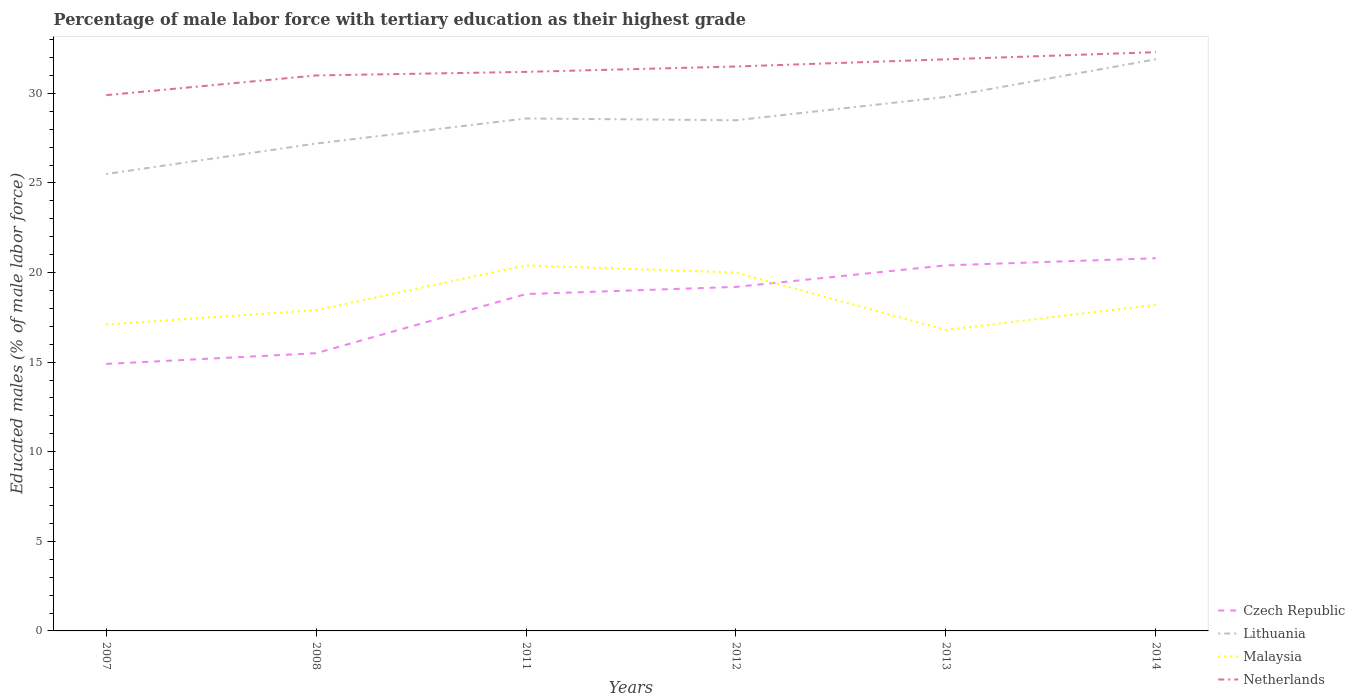How many different coloured lines are there?
Your answer should be very brief. 4. Does the line corresponding to Malaysia intersect with the line corresponding to Lithuania?
Offer a very short reply. No. Across all years, what is the maximum percentage of male labor force with tertiary education in Czech Republic?
Keep it short and to the point. 14.9. What is the total percentage of male labor force with tertiary education in Czech Republic in the graph?
Your answer should be very brief. -0.4. What is the difference between the highest and the second highest percentage of male labor force with tertiary education in Czech Republic?
Give a very brief answer. 5.9. What is the difference between the highest and the lowest percentage of male labor force with tertiary education in Czech Republic?
Keep it short and to the point. 4. Does the graph contain any zero values?
Provide a short and direct response. No. Does the graph contain grids?
Ensure brevity in your answer.  No. How many legend labels are there?
Your answer should be compact. 4. What is the title of the graph?
Provide a short and direct response. Percentage of male labor force with tertiary education as their highest grade. Does "Qatar" appear as one of the legend labels in the graph?
Offer a terse response. No. What is the label or title of the Y-axis?
Offer a very short reply. Educated males (% of male labor force). What is the Educated males (% of male labor force) in Czech Republic in 2007?
Your response must be concise. 14.9. What is the Educated males (% of male labor force) of Malaysia in 2007?
Your answer should be very brief. 17.1. What is the Educated males (% of male labor force) in Netherlands in 2007?
Give a very brief answer. 29.9. What is the Educated males (% of male labor force) of Czech Republic in 2008?
Ensure brevity in your answer.  15.5. What is the Educated males (% of male labor force) of Lithuania in 2008?
Ensure brevity in your answer.  27.2. What is the Educated males (% of male labor force) in Malaysia in 2008?
Ensure brevity in your answer.  17.9. What is the Educated males (% of male labor force) in Netherlands in 2008?
Ensure brevity in your answer.  31. What is the Educated males (% of male labor force) in Czech Republic in 2011?
Ensure brevity in your answer.  18.8. What is the Educated males (% of male labor force) of Lithuania in 2011?
Your response must be concise. 28.6. What is the Educated males (% of male labor force) in Malaysia in 2011?
Keep it short and to the point. 20.4. What is the Educated males (% of male labor force) in Netherlands in 2011?
Offer a terse response. 31.2. What is the Educated males (% of male labor force) of Czech Republic in 2012?
Keep it short and to the point. 19.2. What is the Educated males (% of male labor force) of Lithuania in 2012?
Offer a very short reply. 28.5. What is the Educated males (% of male labor force) of Netherlands in 2012?
Your answer should be compact. 31.5. What is the Educated males (% of male labor force) in Czech Republic in 2013?
Provide a succinct answer. 20.4. What is the Educated males (% of male labor force) in Lithuania in 2013?
Give a very brief answer. 29.8. What is the Educated males (% of male labor force) of Malaysia in 2013?
Your answer should be very brief. 16.8. What is the Educated males (% of male labor force) in Netherlands in 2013?
Keep it short and to the point. 31.9. What is the Educated males (% of male labor force) in Czech Republic in 2014?
Provide a short and direct response. 20.8. What is the Educated males (% of male labor force) of Lithuania in 2014?
Give a very brief answer. 31.9. What is the Educated males (% of male labor force) in Malaysia in 2014?
Provide a succinct answer. 18.2. What is the Educated males (% of male labor force) of Netherlands in 2014?
Your response must be concise. 32.3. Across all years, what is the maximum Educated males (% of male labor force) of Czech Republic?
Your response must be concise. 20.8. Across all years, what is the maximum Educated males (% of male labor force) in Lithuania?
Make the answer very short. 31.9. Across all years, what is the maximum Educated males (% of male labor force) of Malaysia?
Offer a terse response. 20.4. Across all years, what is the maximum Educated males (% of male labor force) of Netherlands?
Give a very brief answer. 32.3. Across all years, what is the minimum Educated males (% of male labor force) in Czech Republic?
Offer a terse response. 14.9. Across all years, what is the minimum Educated males (% of male labor force) of Lithuania?
Ensure brevity in your answer.  25.5. Across all years, what is the minimum Educated males (% of male labor force) in Malaysia?
Offer a very short reply. 16.8. Across all years, what is the minimum Educated males (% of male labor force) of Netherlands?
Make the answer very short. 29.9. What is the total Educated males (% of male labor force) in Czech Republic in the graph?
Offer a very short reply. 109.6. What is the total Educated males (% of male labor force) of Lithuania in the graph?
Your response must be concise. 171.5. What is the total Educated males (% of male labor force) of Malaysia in the graph?
Provide a short and direct response. 110.4. What is the total Educated males (% of male labor force) in Netherlands in the graph?
Provide a short and direct response. 187.8. What is the difference between the Educated males (% of male labor force) of Czech Republic in 2007 and that in 2008?
Offer a very short reply. -0.6. What is the difference between the Educated males (% of male labor force) of Lithuania in 2007 and that in 2008?
Your answer should be compact. -1.7. What is the difference between the Educated males (% of male labor force) of Malaysia in 2007 and that in 2008?
Provide a short and direct response. -0.8. What is the difference between the Educated males (% of male labor force) in Czech Republic in 2007 and that in 2011?
Make the answer very short. -3.9. What is the difference between the Educated males (% of male labor force) in Malaysia in 2007 and that in 2011?
Give a very brief answer. -3.3. What is the difference between the Educated males (% of male labor force) of Lithuania in 2007 and that in 2012?
Keep it short and to the point. -3. What is the difference between the Educated males (% of male labor force) of Lithuania in 2007 and that in 2013?
Offer a very short reply. -4.3. What is the difference between the Educated males (% of male labor force) of Malaysia in 2007 and that in 2013?
Provide a succinct answer. 0.3. What is the difference between the Educated males (% of male labor force) in Netherlands in 2007 and that in 2013?
Give a very brief answer. -2. What is the difference between the Educated males (% of male labor force) of Netherlands in 2007 and that in 2014?
Give a very brief answer. -2.4. What is the difference between the Educated males (% of male labor force) of Czech Republic in 2008 and that in 2011?
Your answer should be compact. -3.3. What is the difference between the Educated males (% of male labor force) in Netherlands in 2008 and that in 2011?
Offer a terse response. -0.2. What is the difference between the Educated males (% of male labor force) in Czech Republic in 2008 and that in 2012?
Offer a very short reply. -3.7. What is the difference between the Educated males (% of male labor force) of Malaysia in 2008 and that in 2012?
Offer a terse response. -2.1. What is the difference between the Educated males (% of male labor force) of Malaysia in 2008 and that in 2013?
Offer a very short reply. 1.1. What is the difference between the Educated males (% of male labor force) of Netherlands in 2008 and that in 2013?
Offer a terse response. -0.9. What is the difference between the Educated males (% of male labor force) in Czech Republic in 2008 and that in 2014?
Offer a very short reply. -5.3. What is the difference between the Educated males (% of male labor force) in Lithuania in 2011 and that in 2012?
Your answer should be very brief. 0.1. What is the difference between the Educated males (% of male labor force) in Malaysia in 2011 and that in 2012?
Offer a terse response. 0.4. What is the difference between the Educated males (% of male labor force) of Netherlands in 2011 and that in 2012?
Make the answer very short. -0.3. What is the difference between the Educated males (% of male labor force) of Czech Republic in 2011 and that in 2013?
Offer a very short reply. -1.6. What is the difference between the Educated males (% of male labor force) in Lithuania in 2011 and that in 2013?
Your answer should be very brief. -1.2. What is the difference between the Educated males (% of male labor force) in Malaysia in 2011 and that in 2013?
Offer a very short reply. 3.6. What is the difference between the Educated males (% of male labor force) of Netherlands in 2011 and that in 2013?
Keep it short and to the point. -0.7. What is the difference between the Educated males (% of male labor force) in Lithuania in 2011 and that in 2014?
Your answer should be compact. -3.3. What is the difference between the Educated males (% of male labor force) of Netherlands in 2011 and that in 2014?
Your answer should be compact. -1.1. What is the difference between the Educated males (% of male labor force) of Czech Republic in 2012 and that in 2013?
Give a very brief answer. -1.2. What is the difference between the Educated males (% of male labor force) in Lithuania in 2012 and that in 2014?
Your response must be concise. -3.4. What is the difference between the Educated males (% of male labor force) of Lithuania in 2013 and that in 2014?
Offer a very short reply. -2.1. What is the difference between the Educated males (% of male labor force) in Netherlands in 2013 and that in 2014?
Your answer should be very brief. -0.4. What is the difference between the Educated males (% of male labor force) in Czech Republic in 2007 and the Educated males (% of male labor force) in Netherlands in 2008?
Provide a short and direct response. -16.1. What is the difference between the Educated males (% of male labor force) of Lithuania in 2007 and the Educated males (% of male labor force) of Netherlands in 2008?
Ensure brevity in your answer.  -5.5. What is the difference between the Educated males (% of male labor force) in Malaysia in 2007 and the Educated males (% of male labor force) in Netherlands in 2008?
Make the answer very short. -13.9. What is the difference between the Educated males (% of male labor force) of Czech Republic in 2007 and the Educated males (% of male labor force) of Lithuania in 2011?
Offer a very short reply. -13.7. What is the difference between the Educated males (% of male labor force) of Czech Republic in 2007 and the Educated males (% of male labor force) of Netherlands in 2011?
Make the answer very short. -16.3. What is the difference between the Educated males (% of male labor force) of Lithuania in 2007 and the Educated males (% of male labor force) of Malaysia in 2011?
Your response must be concise. 5.1. What is the difference between the Educated males (% of male labor force) of Malaysia in 2007 and the Educated males (% of male labor force) of Netherlands in 2011?
Your response must be concise. -14.1. What is the difference between the Educated males (% of male labor force) of Czech Republic in 2007 and the Educated males (% of male labor force) of Malaysia in 2012?
Provide a short and direct response. -5.1. What is the difference between the Educated males (% of male labor force) of Czech Republic in 2007 and the Educated males (% of male labor force) of Netherlands in 2012?
Make the answer very short. -16.6. What is the difference between the Educated males (% of male labor force) in Lithuania in 2007 and the Educated males (% of male labor force) in Malaysia in 2012?
Make the answer very short. 5.5. What is the difference between the Educated males (% of male labor force) in Malaysia in 2007 and the Educated males (% of male labor force) in Netherlands in 2012?
Offer a very short reply. -14.4. What is the difference between the Educated males (% of male labor force) of Czech Republic in 2007 and the Educated males (% of male labor force) of Lithuania in 2013?
Your answer should be compact. -14.9. What is the difference between the Educated males (% of male labor force) in Czech Republic in 2007 and the Educated males (% of male labor force) in Netherlands in 2013?
Your answer should be compact. -17. What is the difference between the Educated males (% of male labor force) of Lithuania in 2007 and the Educated males (% of male labor force) of Malaysia in 2013?
Your response must be concise. 8.7. What is the difference between the Educated males (% of male labor force) in Malaysia in 2007 and the Educated males (% of male labor force) in Netherlands in 2013?
Ensure brevity in your answer.  -14.8. What is the difference between the Educated males (% of male labor force) of Czech Republic in 2007 and the Educated males (% of male labor force) of Netherlands in 2014?
Provide a succinct answer. -17.4. What is the difference between the Educated males (% of male labor force) in Lithuania in 2007 and the Educated males (% of male labor force) in Malaysia in 2014?
Keep it short and to the point. 7.3. What is the difference between the Educated males (% of male labor force) of Lithuania in 2007 and the Educated males (% of male labor force) of Netherlands in 2014?
Your answer should be compact. -6.8. What is the difference between the Educated males (% of male labor force) of Malaysia in 2007 and the Educated males (% of male labor force) of Netherlands in 2014?
Make the answer very short. -15.2. What is the difference between the Educated males (% of male labor force) of Czech Republic in 2008 and the Educated males (% of male labor force) of Malaysia in 2011?
Offer a terse response. -4.9. What is the difference between the Educated males (% of male labor force) of Czech Republic in 2008 and the Educated males (% of male labor force) of Netherlands in 2011?
Your answer should be very brief. -15.7. What is the difference between the Educated males (% of male labor force) of Lithuania in 2008 and the Educated males (% of male labor force) of Malaysia in 2011?
Ensure brevity in your answer.  6.8. What is the difference between the Educated males (% of male labor force) of Lithuania in 2008 and the Educated males (% of male labor force) of Netherlands in 2011?
Make the answer very short. -4. What is the difference between the Educated males (% of male labor force) of Malaysia in 2008 and the Educated males (% of male labor force) of Netherlands in 2011?
Keep it short and to the point. -13.3. What is the difference between the Educated males (% of male labor force) in Czech Republic in 2008 and the Educated males (% of male labor force) in Lithuania in 2012?
Provide a short and direct response. -13. What is the difference between the Educated males (% of male labor force) of Czech Republic in 2008 and the Educated males (% of male labor force) of Malaysia in 2012?
Keep it short and to the point. -4.5. What is the difference between the Educated males (% of male labor force) of Lithuania in 2008 and the Educated males (% of male labor force) of Netherlands in 2012?
Provide a succinct answer. -4.3. What is the difference between the Educated males (% of male labor force) in Czech Republic in 2008 and the Educated males (% of male labor force) in Lithuania in 2013?
Your response must be concise. -14.3. What is the difference between the Educated males (% of male labor force) in Czech Republic in 2008 and the Educated males (% of male labor force) in Netherlands in 2013?
Provide a short and direct response. -16.4. What is the difference between the Educated males (% of male labor force) of Lithuania in 2008 and the Educated males (% of male labor force) of Malaysia in 2013?
Provide a short and direct response. 10.4. What is the difference between the Educated males (% of male labor force) in Lithuania in 2008 and the Educated males (% of male labor force) in Netherlands in 2013?
Provide a short and direct response. -4.7. What is the difference between the Educated males (% of male labor force) in Malaysia in 2008 and the Educated males (% of male labor force) in Netherlands in 2013?
Give a very brief answer. -14. What is the difference between the Educated males (% of male labor force) in Czech Republic in 2008 and the Educated males (% of male labor force) in Lithuania in 2014?
Your answer should be very brief. -16.4. What is the difference between the Educated males (% of male labor force) of Czech Republic in 2008 and the Educated males (% of male labor force) of Netherlands in 2014?
Make the answer very short. -16.8. What is the difference between the Educated males (% of male labor force) in Lithuania in 2008 and the Educated males (% of male labor force) in Netherlands in 2014?
Make the answer very short. -5.1. What is the difference between the Educated males (% of male labor force) of Malaysia in 2008 and the Educated males (% of male labor force) of Netherlands in 2014?
Your response must be concise. -14.4. What is the difference between the Educated males (% of male labor force) in Czech Republic in 2011 and the Educated males (% of male labor force) in Lithuania in 2012?
Ensure brevity in your answer.  -9.7. What is the difference between the Educated males (% of male labor force) of Czech Republic in 2011 and the Educated males (% of male labor force) of Malaysia in 2012?
Your answer should be very brief. -1.2. What is the difference between the Educated males (% of male labor force) in Czech Republic in 2011 and the Educated males (% of male labor force) in Netherlands in 2012?
Make the answer very short. -12.7. What is the difference between the Educated males (% of male labor force) in Czech Republic in 2011 and the Educated males (% of male labor force) in Lithuania in 2013?
Provide a succinct answer. -11. What is the difference between the Educated males (% of male labor force) in Czech Republic in 2011 and the Educated males (% of male labor force) in Malaysia in 2013?
Offer a very short reply. 2. What is the difference between the Educated males (% of male labor force) of Lithuania in 2011 and the Educated males (% of male labor force) of Malaysia in 2013?
Ensure brevity in your answer.  11.8. What is the difference between the Educated males (% of male labor force) in Czech Republic in 2011 and the Educated males (% of male labor force) in Malaysia in 2014?
Offer a terse response. 0.6. What is the difference between the Educated males (% of male labor force) in Lithuania in 2011 and the Educated males (% of male labor force) in Malaysia in 2014?
Offer a very short reply. 10.4. What is the difference between the Educated males (% of male labor force) of Malaysia in 2011 and the Educated males (% of male labor force) of Netherlands in 2014?
Offer a terse response. -11.9. What is the difference between the Educated males (% of male labor force) in Czech Republic in 2012 and the Educated males (% of male labor force) in Lithuania in 2013?
Keep it short and to the point. -10.6. What is the difference between the Educated males (% of male labor force) of Lithuania in 2012 and the Educated males (% of male labor force) of Malaysia in 2013?
Keep it short and to the point. 11.7. What is the difference between the Educated males (% of male labor force) of Lithuania in 2012 and the Educated males (% of male labor force) of Netherlands in 2013?
Your answer should be very brief. -3.4. What is the difference between the Educated males (% of male labor force) in Czech Republic in 2012 and the Educated males (% of male labor force) in Lithuania in 2014?
Your answer should be very brief. -12.7. What is the difference between the Educated males (% of male labor force) in Lithuania in 2012 and the Educated males (% of male labor force) in Netherlands in 2014?
Give a very brief answer. -3.8. What is the difference between the Educated males (% of male labor force) in Malaysia in 2012 and the Educated males (% of male labor force) in Netherlands in 2014?
Give a very brief answer. -12.3. What is the difference between the Educated males (% of male labor force) of Czech Republic in 2013 and the Educated males (% of male labor force) of Lithuania in 2014?
Your answer should be very brief. -11.5. What is the difference between the Educated males (% of male labor force) in Lithuania in 2013 and the Educated males (% of male labor force) in Netherlands in 2014?
Provide a succinct answer. -2.5. What is the difference between the Educated males (% of male labor force) of Malaysia in 2013 and the Educated males (% of male labor force) of Netherlands in 2014?
Your answer should be compact. -15.5. What is the average Educated males (% of male labor force) in Czech Republic per year?
Make the answer very short. 18.27. What is the average Educated males (% of male labor force) in Lithuania per year?
Provide a short and direct response. 28.58. What is the average Educated males (% of male labor force) of Netherlands per year?
Ensure brevity in your answer.  31.3. In the year 2007, what is the difference between the Educated males (% of male labor force) in Czech Republic and Educated males (% of male labor force) in Lithuania?
Make the answer very short. -10.6. In the year 2008, what is the difference between the Educated males (% of male labor force) of Czech Republic and Educated males (% of male labor force) of Netherlands?
Offer a very short reply. -15.5. In the year 2008, what is the difference between the Educated males (% of male labor force) in Lithuania and Educated males (% of male labor force) in Malaysia?
Offer a terse response. 9.3. In the year 2008, what is the difference between the Educated males (% of male labor force) in Malaysia and Educated males (% of male labor force) in Netherlands?
Keep it short and to the point. -13.1. In the year 2011, what is the difference between the Educated males (% of male labor force) in Czech Republic and Educated males (% of male labor force) in Netherlands?
Offer a terse response. -12.4. In the year 2011, what is the difference between the Educated males (% of male labor force) in Malaysia and Educated males (% of male labor force) in Netherlands?
Give a very brief answer. -10.8. In the year 2012, what is the difference between the Educated males (% of male labor force) in Czech Republic and Educated males (% of male labor force) in Netherlands?
Offer a terse response. -12.3. In the year 2012, what is the difference between the Educated males (% of male labor force) in Lithuania and Educated males (% of male labor force) in Malaysia?
Offer a terse response. 8.5. In the year 2012, what is the difference between the Educated males (% of male labor force) of Lithuania and Educated males (% of male labor force) of Netherlands?
Offer a terse response. -3. In the year 2013, what is the difference between the Educated males (% of male labor force) of Czech Republic and Educated males (% of male labor force) of Lithuania?
Ensure brevity in your answer.  -9.4. In the year 2013, what is the difference between the Educated males (% of male labor force) in Lithuania and Educated males (% of male labor force) in Malaysia?
Offer a very short reply. 13. In the year 2013, what is the difference between the Educated males (% of male labor force) of Malaysia and Educated males (% of male labor force) of Netherlands?
Offer a terse response. -15.1. In the year 2014, what is the difference between the Educated males (% of male labor force) of Czech Republic and Educated males (% of male labor force) of Lithuania?
Provide a succinct answer. -11.1. In the year 2014, what is the difference between the Educated males (% of male labor force) in Czech Republic and Educated males (% of male labor force) in Malaysia?
Offer a terse response. 2.6. In the year 2014, what is the difference between the Educated males (% of male labor force) of Czech Republic and Educated males (% of male labor force) of Netherlands?
Your answer should be compact. -11.5. In the year 2014, what is the difference between the Educated males (% of male labor force) in Lithuania and Educated males (% of male labor force) in Malaysia?
Provide a succinct answer. 13.7. In the year 2014, what is the difference between the Educated males (% of male labor force) of Malaysia and Educated males (% of male labor force) of Netherlands?
Make the answer very short. -14.1. What is the ratio of the Educated males (% of male labor force) in Czech Republic in 2007 to that in 2008?
Your answer should be very brief. 0.96. What is the ratio of the Educated males (% of male labor force) in Lithuania in 2007 to that in 2008?
Provide a succinct answer. 0.94. What is the ratio of the Educated males (% of male labor force) of Malaysia in 2007 to that in 2008?
Ensure brevity in your answer.  0.96. What is the ratio of the Educated males (% of male labor force) in Netherlands in 2007 to that in 2008?
Offer a very short reply. 0.96. What is the ratio of the Educated males (% of male labor force) of Czech Republic in 2007 to that in 2011?
Ensure brevity in your answer.  0.79. What is the ratio of the Educated males (% of male labor force) of Lithuania in 2007 to that in 2011?
Provide a short and direct response. 0.89. What is the ratio of the Educated males (% of male labor force) in Malaysia in 2007 to that in 2011?
Offer a very short reply. 0.84. What is the ratio of the Educated males (% of male labor force) of Netherlands in 2007 to that in 2011?
Give a very brief answer. 0.96. What is the ratio of the Educated males (% of male labor force) in Czech Republic in 2007 to that in 2012?
Make the answer very short. 0.78. What is the ratio of the Educated males (% of male labor force) of Lithuania in 2007 to that in 2012?
Provide a short and direct response. 0.89. What is the ratio of the Educated males (% of male labor force) of Malaysia in 2007 to that in 2012?
Your answer should be very brief. 0.85. What is the ratio of the Educated males (% of male labor force) of Netherlands in 2007 to that in 2012?
Ensure brevity in your answer.  0.95. What is the ratio of the Educated males (% of male labor force) of Czech Republic in 2007 to that in 2013?
Offer a terse response. 0.73. What is the ratio of the Educated males (% of male labor force) in Lithuania in 2007 to that in 2013?
Your answer should be very brief. 0.86. What is the ratio of the Educated males (% of male labor force) in Malaysia in 2007 to that in 2013?
Offer a very short reply. 1.02. What is the ratio of the Educated males (% of male labor force) of Netherlands in 2007 to that in 2013?
Give a very brief answer. 0.94. What is the ratio of the Educated males (% of male labor force) in Czech Republic in 2007 to that in 2014?
Give a very brief answer. 0.72. What is the ratio of the Educated males (% of male labor force) of Lithuania in 2007 to that in 2014?
Ensure brevity in your answer.  0.8. What is the ratio of the Educated males (% of male labor force) of Malaysia in 2007 to that in 2014?
Offer a very short reply. 0.94. What is the ratio of the Educated males (% of male labor force) in Netherlands in 2007 to that in 2014?
Offer a very short reply. 0.93. What is the ratio of the Educated males (% of male labor force) of Czech Republic in 2008 to that in 2011?
Provide a short and direct response. 0.82. What is the ratio of the Educated males (% of male labor force) in Lithuania in 2008 to that in 2011?
Ensure brevity in your answer.  0.95. What is the ratio of the Educated males (% of male labor force) of Malaysia in 2008 to that in 2011?
Keep it short and to the point. 0.88. What is the ratio of the Educated males (% of male labor force) of Czech Republic in 2008 to that in 2012?
Your answer should be compact. 0.81. What is the ratio of the Educated males (% of male labor force) of Lithuania in 2008 to that in 2012?
Your answer should be very brief. 0.95. What is the ratio of the Educated males (% of male labor force) of Malaysia in 2008 to that in 2012?
Give a very brief answer. 0.9. What is the ratio of the Educated males (% of male labor force) of Netherlands in 2008 to that in 2012?
Your answer should be compact. 0.98. What is the ratio of the Educated males (% of male labor force) in Czech Republic in 2008 to that in 2013?
Make the answer very short. 0.76. What is the ratio of the Educated males (% of male labor force) in Lithuania in 2008 to that in 2013?
Your answer should be compact. 0.91. What is the ratio of the Educated males (% of male labor force) of Malaysia in 2008 to that in 2013?
Provide a succinct answer. 1.07. What is the ratio of the Educated males (% of male labor force) of Netherlands in 2008 to that in 2013?
Provide a short and direct response. 0.97. What is the ratio of the Educated males (% of male labor force) of Czech Republic in 2008 to that in 2014?
Offer a terse response. 0.75. What is the ratio of the Educated males (% of male labor force) in Lithuania in 2008 to that in 2014?
Offer a terse response. 0.85. What is the ratio of the Educated males (% of male labor force) of Malaysia in 2008 to that in 2014?
Offer a very short reply. 0.98. What is the ratio of the Educated males (% of male labor force) of Netherlands in 2008 to that in 2014?
Give a very brief answer. 0.96. What is the ratio of the Educated males (% of male labor force) of Czech Republic in 2011 to that in 2012?
Keep it short and to the point. 0.98. What is the ratio of the Educated males (% of male labor force) in Netherlands in 2011 to that in 2012?
Your answer should be compact. 0.99. What is the ratio of the Educated males (% of male labor force) of Czech Republic in 2011 to that in 2013?
Give a very brief answer. 0.92. What is the ratio of the Educated males (% of male labor force) of Lithuania in 2011 to that in 2013?
Keep it short and to the point. 0.96. What is the ratio of the Educated males (% of male labor force) of Malaysia in 2011 to that in 2013?
Your answer should be very brief. 1.21. What is the ratio of the Educated males (% of male labor force) of Netherlands in 2011 to that in 2013?
Provide a succinct answer. 0.98. What is the ratio of the Educated males (% of male labor force) of Czech Republic in 2011 to that in 2014?
Offer a terse response. 0.9. What is the ratio of the Educated males (% of male labor force) in Lithuania in 2011 to that in 2014?
Give a very brief answer. 0.9. What is the ratio of the Educated males (% of male labor force) in Malaysia in 2011 to that in 2014?
Make the answer very short. 1.12. What is the ratio of the Educated males (% of male labor force) of Netherlands in 2011 to that in 2014?
Make the answer very short. 0.97. What is the ratio of the Educated males (% of male labor force) of Lithuania in 2012 to that in 2013?
Make the answer very short. 0.96. What is the ratio of the Educated males (% of male labor force) in Malaysia in 2012 to that in 2013?
Offer a very short reply. 1.19. What is the ratio of the Educated males (% of male labor force) of Netherlands in 2012 to that in 2013?
Your answer should be compact. 0.99. What is the ratio of the Educated males (% of male labor force) of Czech Republic in 2012 to that in 2014?
Keep it short and to the point. 0.92. What is the ratio of the Educated males (% of male labor force) of Lithuania in 2012 to that in 2014?
Offer a very short reply. 0.89. What is the ratio of the Educated males (% of male labor force) of Malaysia in 2012 to that in 2014?
Keep it short and to the point. 1.1. What is the ratio of the Educated males (% of male labor force) in Netherlands in 2012 to that in 2014?
Offer a very short reply. 0.98. What is the ratio of the Educated males (% of male labor force) in Czech Republic in 2013 to that in 2014?
Your answer should be very brief. 0.98. What is the ratio of the Educated males (% of male labor force) of Lithuania in 2013 to that in 2014?
Keep it short and to the point. 0.93. What is the ratio of the Educated males (% of male labor force) in Malaysia in 2013 to that in 2014?
Provide a short and direct response. 0.92. What is the ratio of the Educated males (% of male labor force) in Netherlands in 2013 to that in 2014?
Your response must be concise. 0.99. What is the difference between the highest and the second highest Educated males (% of male labor force) of Czech Republic?
Make the answer very short. 0.4. What is the difference between the highest and the second highest Educated males (% of male labor force) in Lithuania?
Ensure brevity in your answer.  2.1. What is the difference between the highest and the second highest Educated males (% of male labor force) in Malaysia?
Ensure brevity in your answer.  0.4. What is the difference between the highest and the lowest Educated males (% of male labor force) of Malaysia?
Your response must be concise. 3.6. What is the difference between the highest and the lowest Educated males (% of male labor force) of Netherlands?
Make the answer very short. 2.4. 